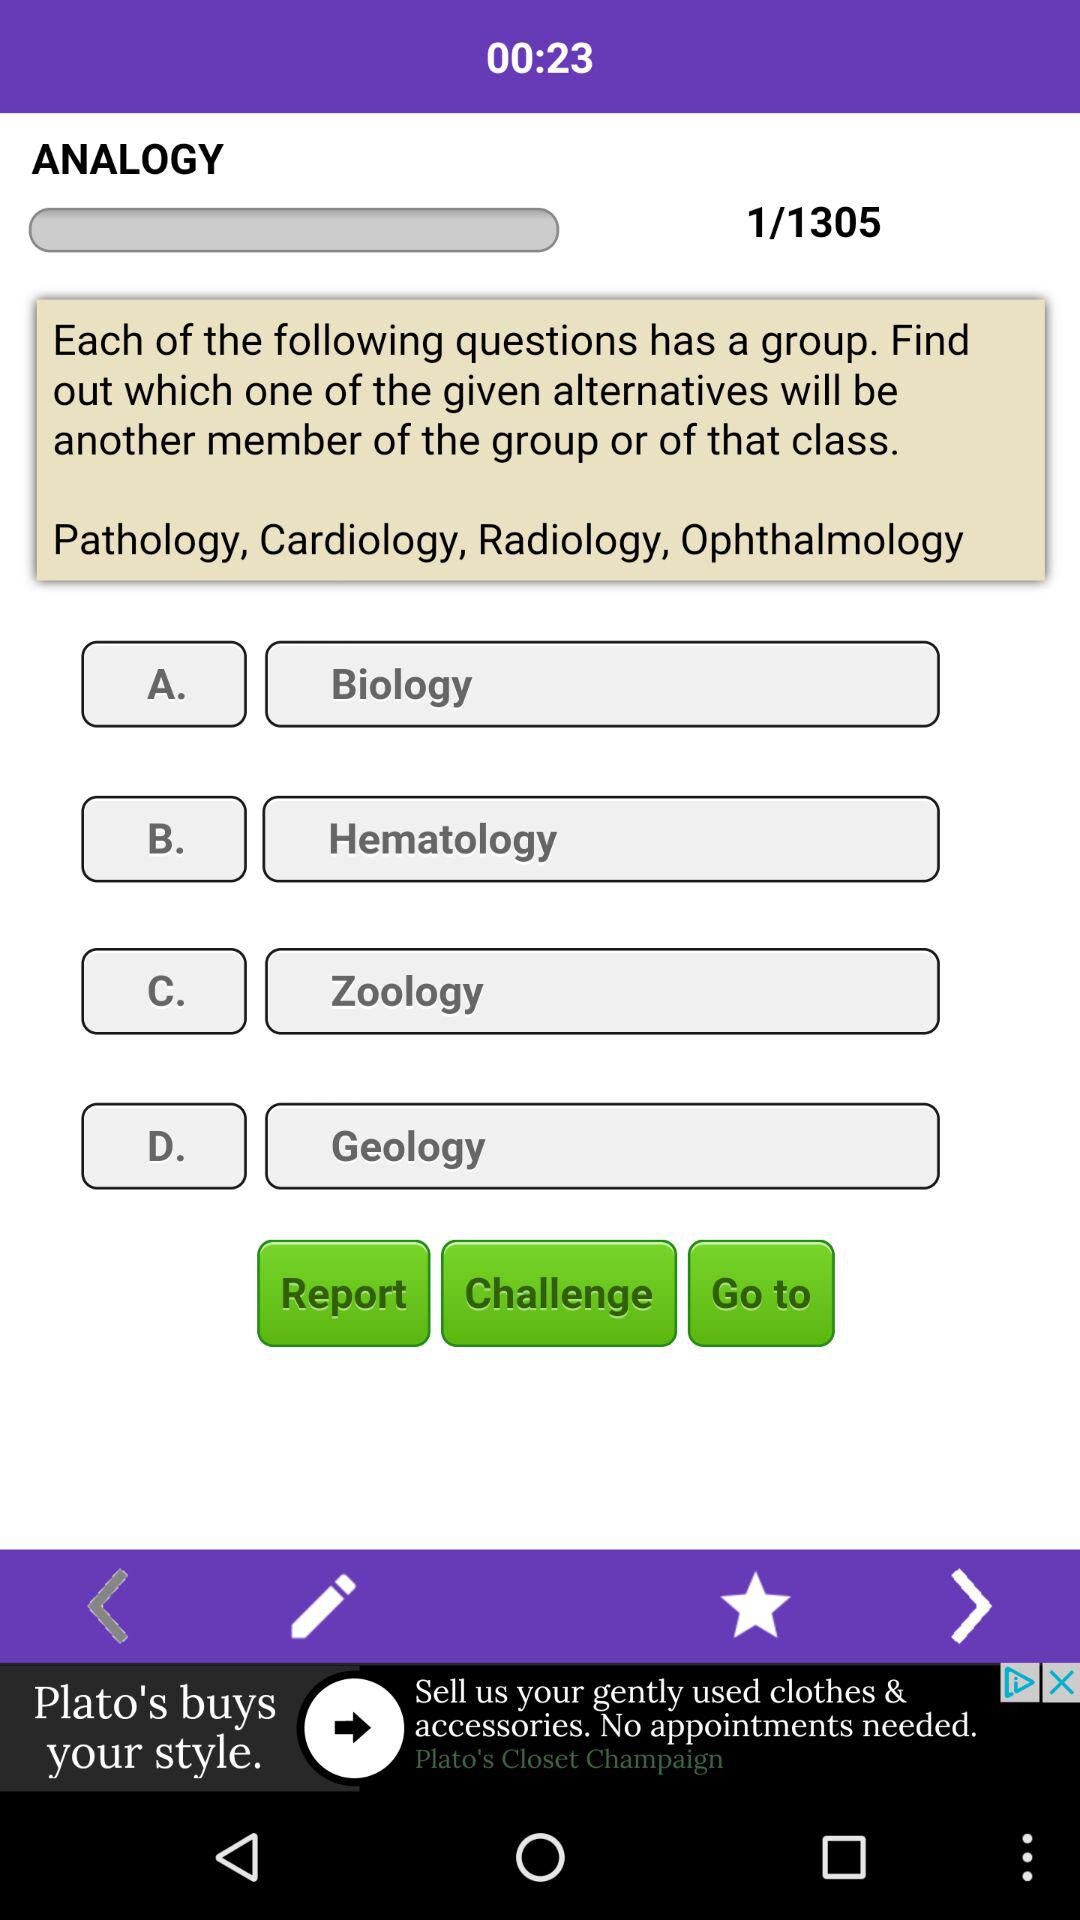Which page number are we currently on? You are on the first page. 